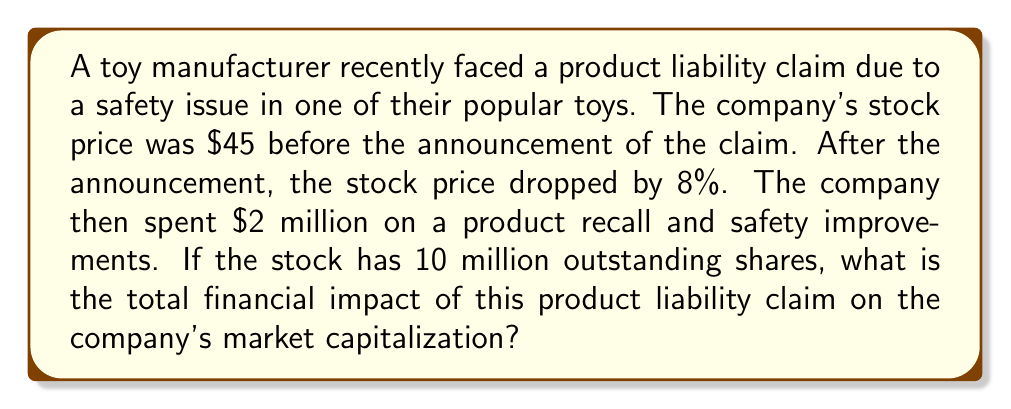Solve this math problem. Let's approach this problem step-by-step:

1. Calculate the stock price after the initial drop:
   Initial price = $45
   Drop percentage = 8% = 0.08
   Price drop = $45 * 0.08 = $3.60
   New price = $45 - $3.60 = $41.40

2. Calculate the initial market capitalization:
   Market cap = Stock price * Number of outstanding shares
   Initial market cap = $45 * 10,000,000 = $450,000,000

3. Calculate the market capitalization after the price drop:
   New market cap = $41.40 * 10,000,000 = $414,000,000

4. Calculate the impact of the price drop on market cap:
   Impact of price drop = Initial market cap - New market cap
   $450,000,000 - $414,000,000 = $36,000,000

5. Add the cost of the product recall and safety improvements:
   Additional cost = $2,000,000

6. Calculate the total financial impact:
   Total impact = Impact of price drop + Additional cost
   $36,000,000 + $2,000,000 = $38,000,000

The total financial impact can be expressed mathematically as:

$$\text{Total Impact} = (P_0 - P_1) * S + C$$

Where:
$P_0$ = Initial stock price
$P_1$ = Stock price after drop
$S$ = Number of outstanding shares
$C$ = Additional costs

Plugging in the values:

$$\text{Total Impact} = ($45 - $41.40) * 10,000,000 + $2,000,000 = $38,000,000$$
Answer: $38,000,000 